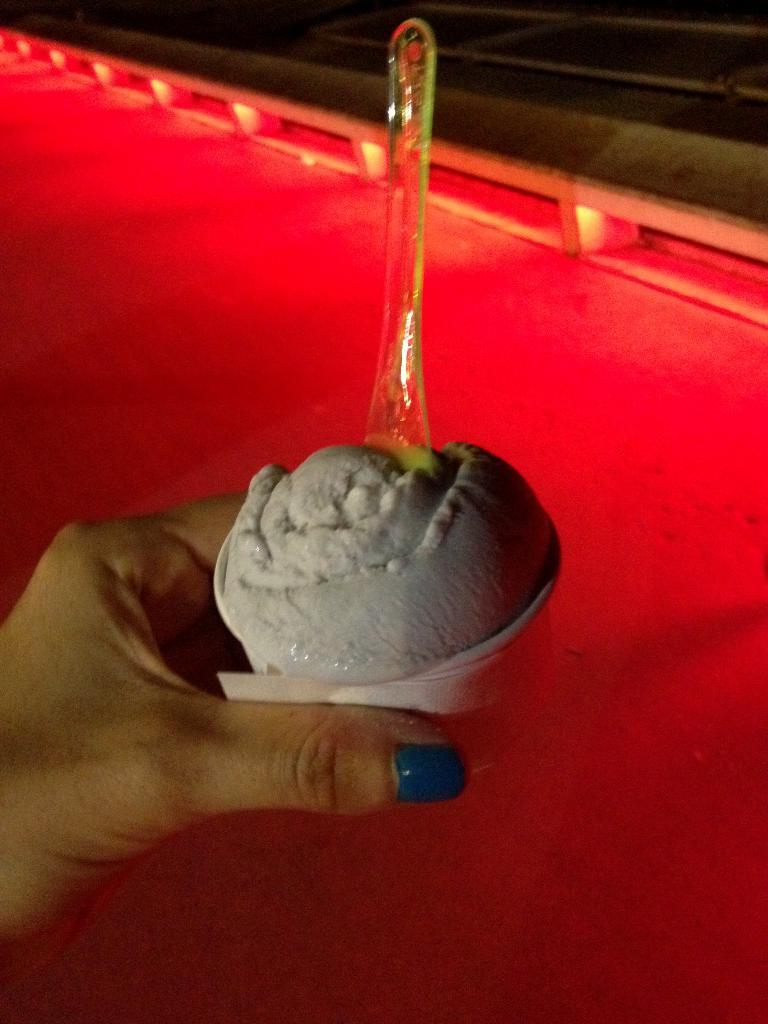Who is present in the image? There is a person in the image. What is the person holding in the image? The person is holding a cup with ice cream. What utensil is on the cup? There is a spoon on the cup. What type of flooring is visible in the image? There is a red color carpet in the image. What architectural feature can be seen in the image? There is railing visible in the image. Can you describe the aftermath of the donkey's interaction with the ant in the image? There is no donkey or ant present in the image, so there is no aftermath to describe. 